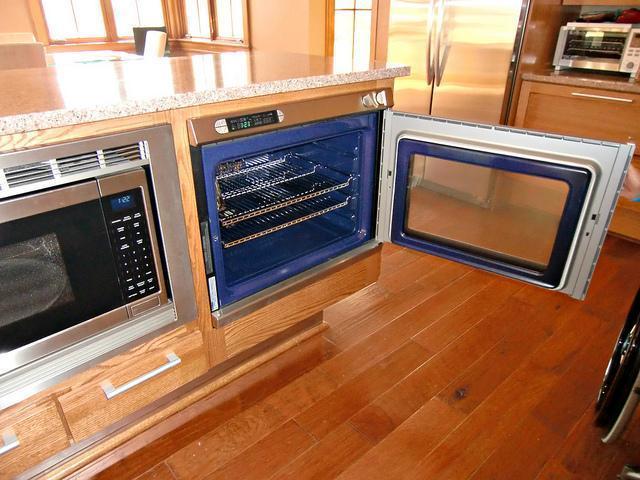What is the state of the blue item?
Select the correct answer and articulate reasoning with the following format: 'Answer: answer
Rationale: rationale.'
Options: Closed, invisible, smashed, open. Answer: open.
Rationale: The door is open on it. 